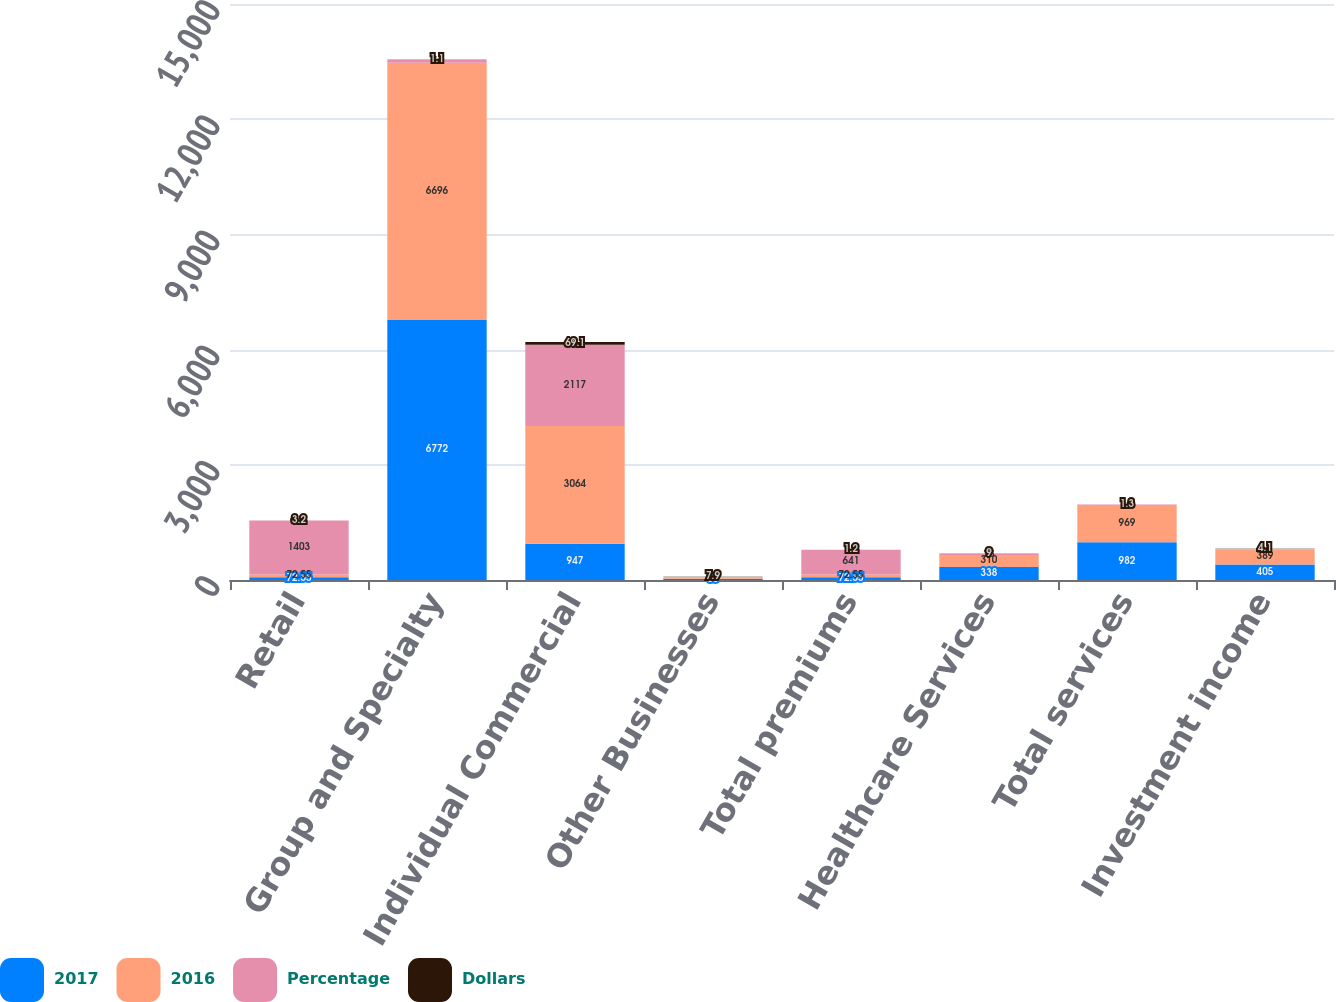Convert chart. <chart><loc_0><loc_0><loc_500><loc_500><stacked_bar_chart><ecel><fcel>Retail<fcel>Group and Specialty<fcel>Individual Commercial<fcel>Other Businesses<fcel>Total premiums<fcel>Healthcare Services<fcel>Total services<fcel>Investment income<nl><fcel>2017<fcel>72.55<fcel>6772<fcel>947<fcel>35<fcel>72.55<fcel>338<fcel>982<fcel>405<nl><fcel>2016<fcel>72.55<fcel>6696<fcel>3064<fcel>38<fcel>72.55<fcel>310<fcel>969<fcel>389<nl><fcel>Percentage<fcel>1403<fcel>76<fcel>2117<fcel>3<fcel>641<fcel>28<fcel>13<fcel>16<nl><fcel>Dollars<fcel>3.2<fcel>1.1<fcel>69.1<fcel>7.9<fcel>1.2<fcel>9<fcel>1.3<fcel>4.1<nl></chart> 